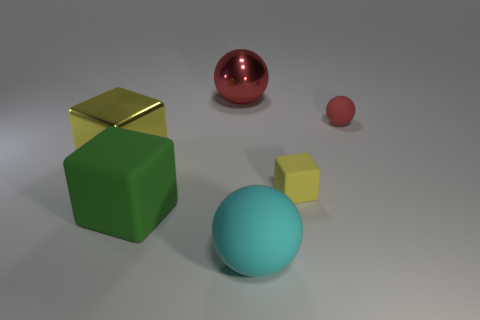Do the tiny matte ball and the large metallic ball have the same color?
Your answer should be compact. Yes. How big is the yellow matte object?
Your response must be concise. Small. Is the size of the red thing to the right of the cyan matte ball the same as the big cyan matte sphere?
Ensure brevity in your answer.  No. What is the size of the matte sphere behind the yellow rubber object?
Your answer should be very brief. Small. What shape is the tiny thing that is the same color as the big shiny sphere?
Your answer should be compact. Sphere. What material is the block on the right side of the sphere that is in front of the big cube in front of the small matte block made of?
Your response must be concise. Rubber. What number of big objects are yellow shiny objects or yellow things?
Provide a succinct answer. 1. What number of other things are there of the same size as the yellow metal thing?
Your answer should be very brief. 3. Does the big metal thing that is behind the big metallic block have the same shape as the green object?
Your answer should be very brief. No. The large matte thing that is the same shape as the large red metal object is what color?
Keep it short and to the point. Cyan. 